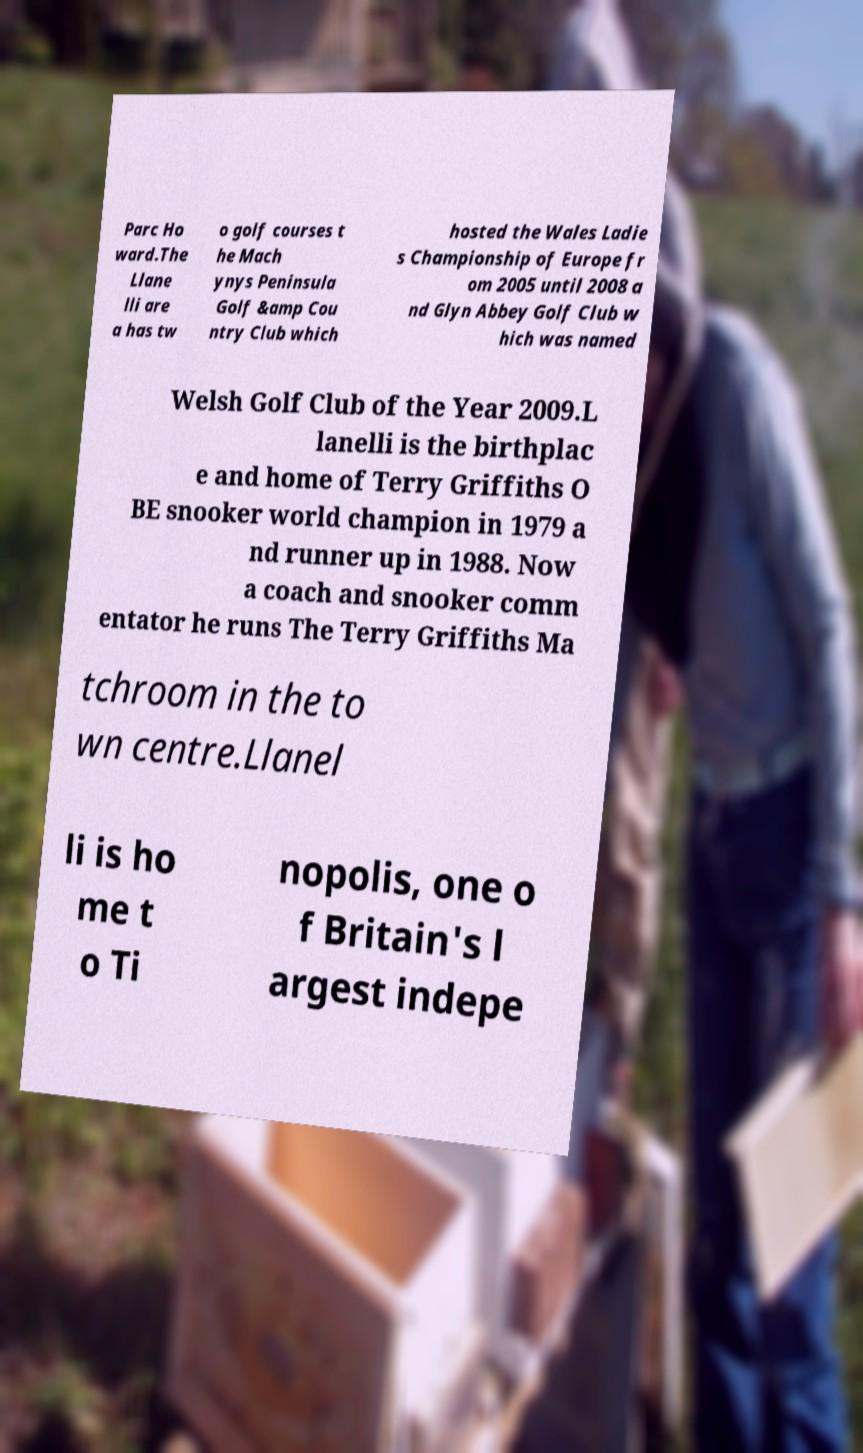There's text embedded in this image that I need extracted. Can you transcribe it verbatim? Parc Ho ward.The Llane lli are a has tw o golf courses t he Mach ynys Peninsula Golf &amp Cou ntry Club which hosted the Wales Ladie s Championship of Europe fr om 2005 until 2008 a nd Glyn Abbey Golf Club w hich was named Welsh Golf Club of the Year 2009.L lanelli is the birthplac e and home of Terry Griffiths O BE snooker world champion in 1979 a nd runner up in 1988. Now a coach and snooker comm entator he runs The Terry Griffiths Ma tchroom in the to wn centre.Llanel li is ho me t o Ti nopolis, one o f Britain's l argest indepe 